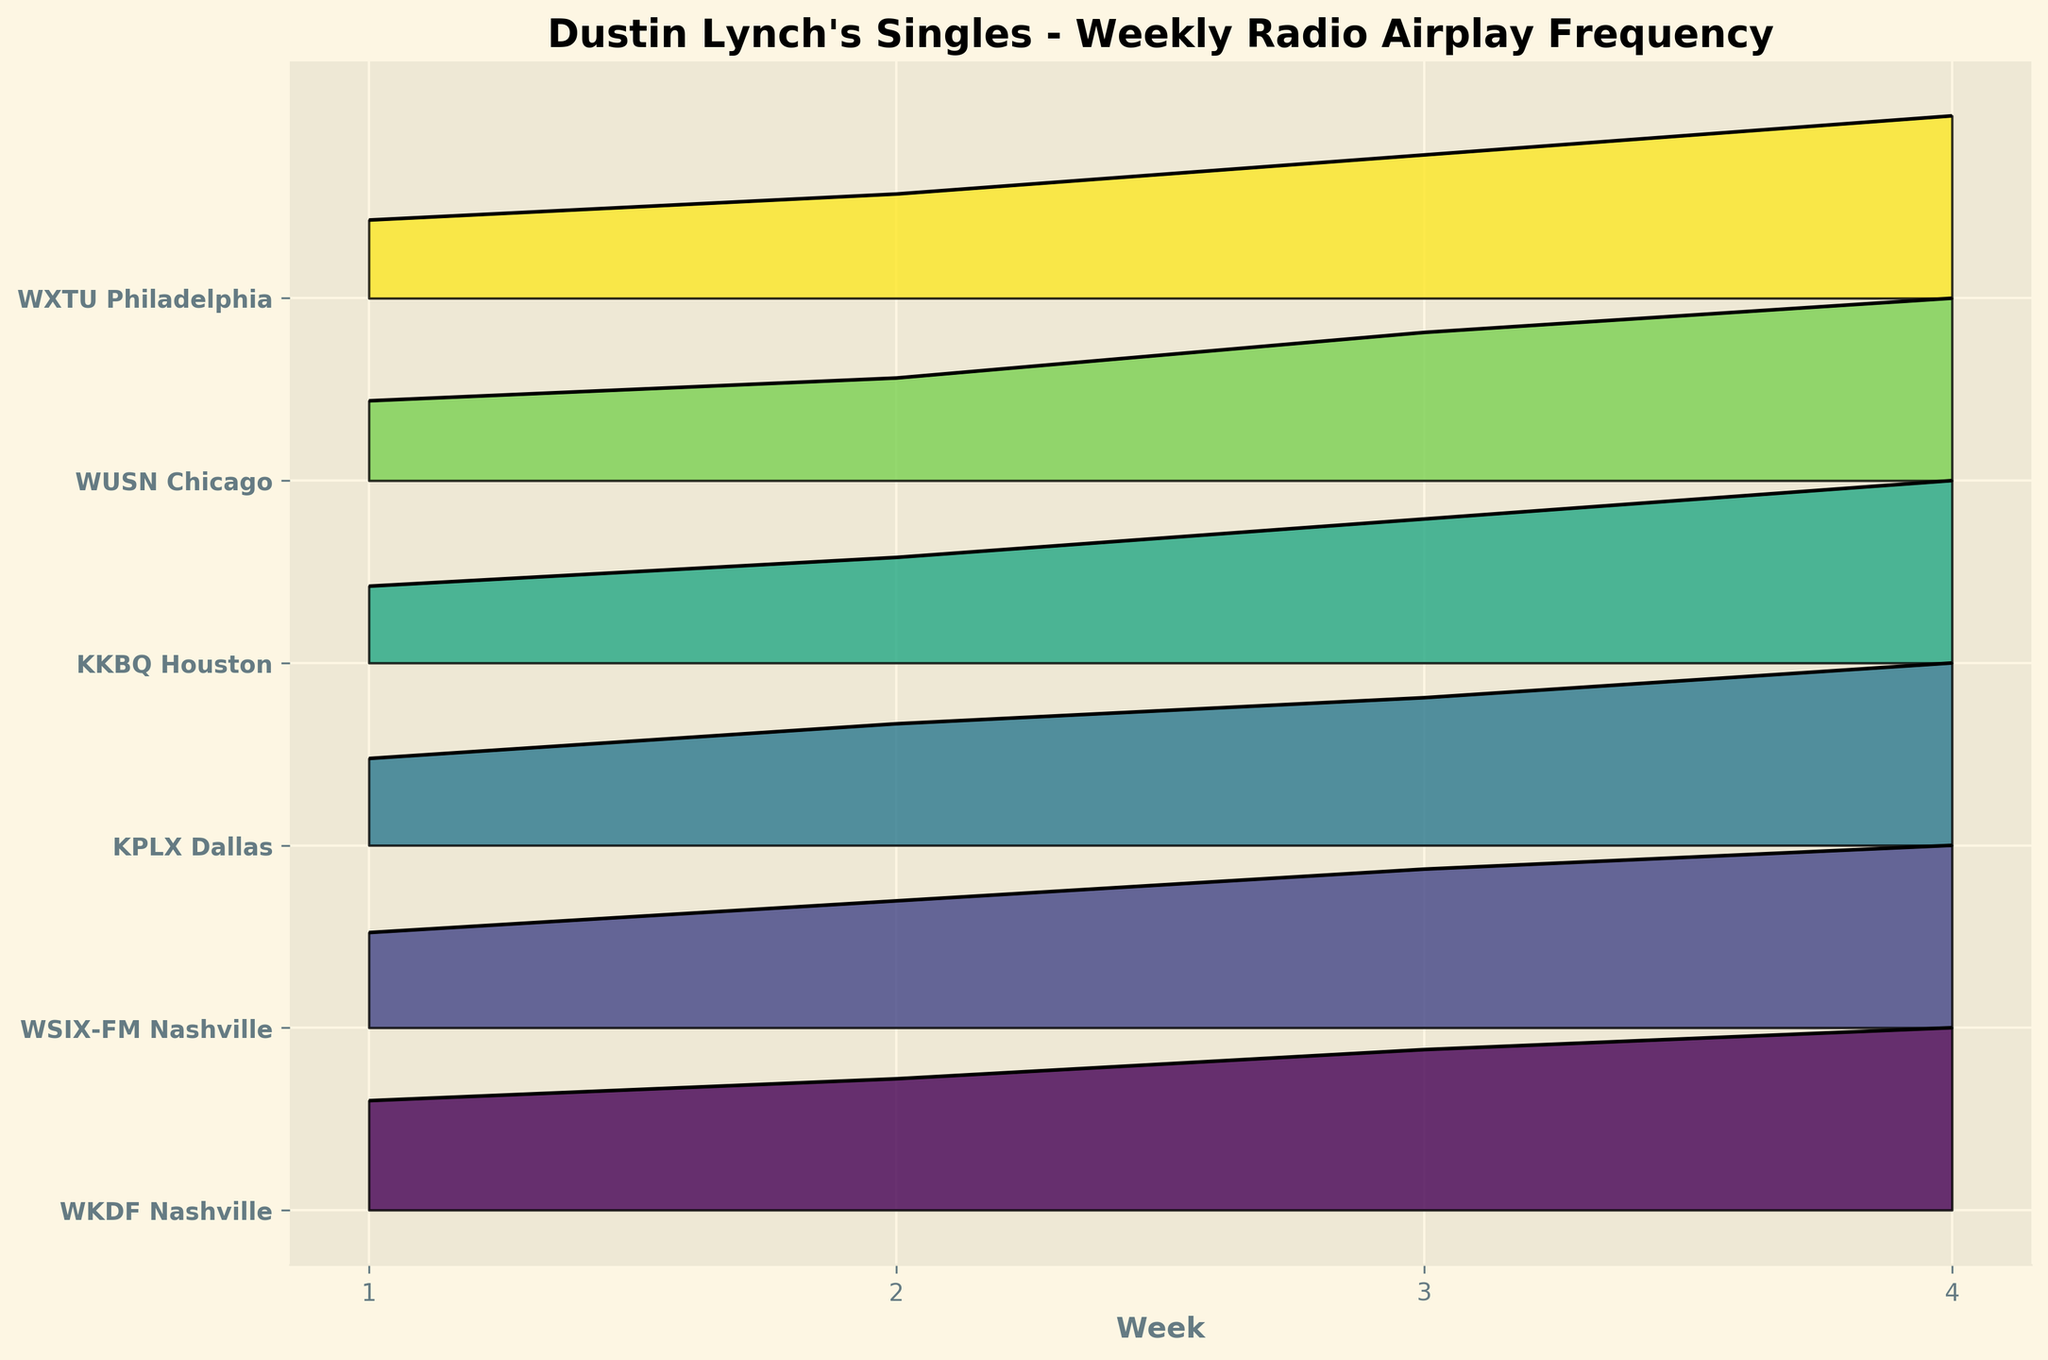What is the title of the figure? The title is usually displayed at the top of the figure, describing the overall content. Here, it reads "Dustin Lynch's Singles - Weekly Radio Airplay Frequency".
Answer: "Dustin Lynch's Singles - Weekly Radio Airplay Frequency" Which station had the highest frequency in Week 4? Check the top of the Week 4 peaks for all stations. WKDF Nashville has the highest frequency.
Answer: WKDF Nashville What are the weeks displayed on the x-axis? The x-axis represents the weeks and is labeled with numbers. Here, the weeks are 1, 2, 3, and 4.
Answer: 1, 2, 3, 4 Which station has the lowest frequency in Week 1? Look at the Week 1 peaks and identify the smallest one. WXTU Philadelphia has the lowest frequency.
Answer: WXTU Philadelphia By how much did the frequency increase from Week 1 to Week 4 for WUSN Chicago? Subtract the Week 1 frequency from the Week 4 frequency for WUSN Chicago. Week 4 frequency (16) - Week 1 frequency (7) = 9.
Answer: 9 Which station shows the steepest increase in airplay frequency over time? Identify the station with the steepest slope when comparing the initial and final frequencies. WKDF Nashville shows the steepest increase.
Answer: WKDF Nashville What is the average frequency of airplay for KPLX Dallas across all weeks? Sum the frequencies across all weeks for KPLX Dallas and divide by the number of weeks. (10 + 14 + 17 + 21) / 4 = 62 / 4 = 15.5.
Answer: 15.5 For Week 2, which two stations have the closest frequencies? Compare the Week 2 frequencies and find the pair with the smallest difference: KKBQ Houston (11) and WUSN Chicago (9) have a difference of 2.
Answer: KKBQ Houston and WUSN Chicago Which station's frequency increased the least from Week 1 to Week 4? Compute the differences between Week 1 and Week 4 frequencies for all stations and find the smallest difference. WXTU Philadelphia has the smallest increase (14 - 6 = 8).
Answer: WXTU Philadelphia What is the cumulative frequency of all stations in Week 3? Sum the frequencies of all stations in Week 3: 22 (WKDF) + 20 (WSIX) + 17 (KPLX) + 15 (KKBQ) + 13 (WUSN) + 11 (WXTU) = 98.
Answer: 98 